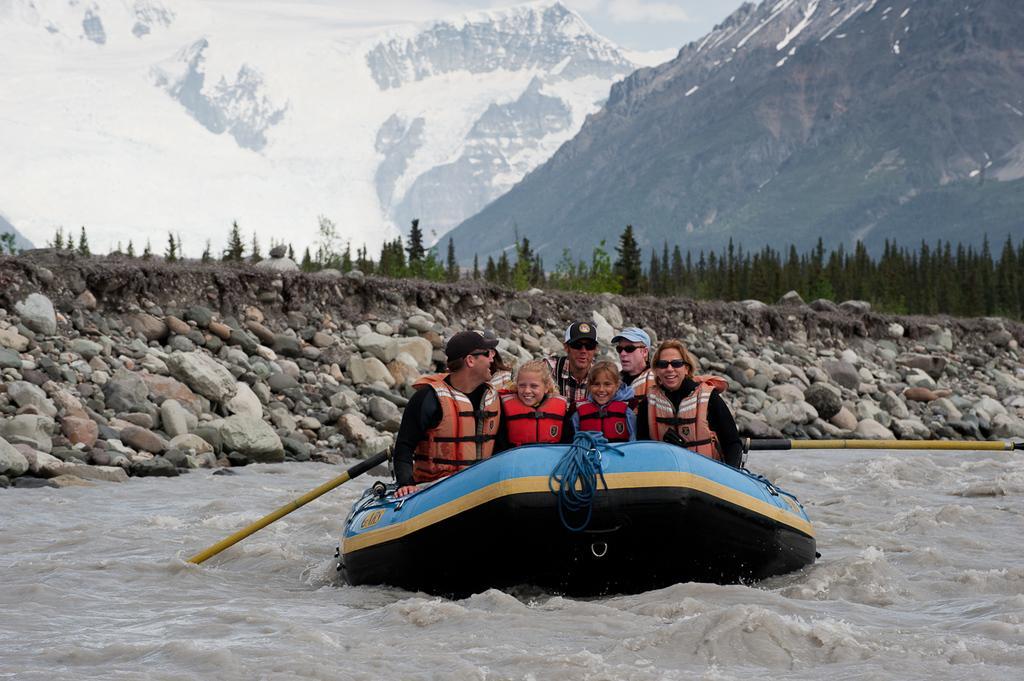Please provide a concise description of this image. In this image I can see water and in it I can see a boat. I can also see few people are sitting on this boat and I can see all of them are wearing water jacket. I can also see few of them are wearing caps and few of them are wearing shades. In the background I can see stones, number of trees, mountains and snow. 